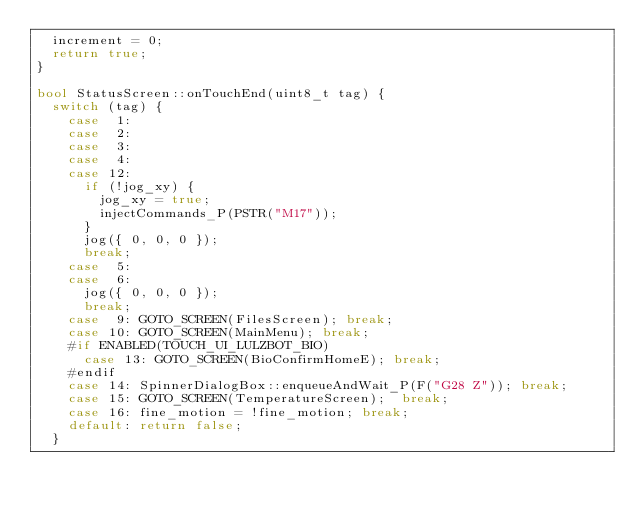Convert code to text. <code><loc_0><loc_0><loc_500><loc_500><_C++_>  increment = 0;
  return true;
}

bool StatusScreen::onTouchEnd(uint8_t tag) {
  switch (tag) {
    case  1:
    case  2:
    case  3:
    case  4:
    case 12:
      if (!jog_xy) {
        jog_xy = true;
        injectCommands_P(PSTR("M17"));
      }
      jog({ 0, 0, 0 });
      break;
    case  5:
    case  6:
      jog({ 0, 0, 0 });
      break;
    case  9: GOTO_SCREEN(FilesScreen); break;
    case 10: GOTO_SCREEN(MainMenu); break;
    #if ENABLED(TOUCH_UI_LULZBOT_BIO)
      case 13: GOTO_SCREEN(BioConfirmHomeE); break;
    #endif
    case 14: SpinnerDialogBox::enqueueAndWait_P(F("G28 Z")); break;
    case 15: GOTO_SCREEN(TemperatureScreen);  break;
    case 16: fine_motion = !fine_motion; break;
    default: return false;
  }</code> 